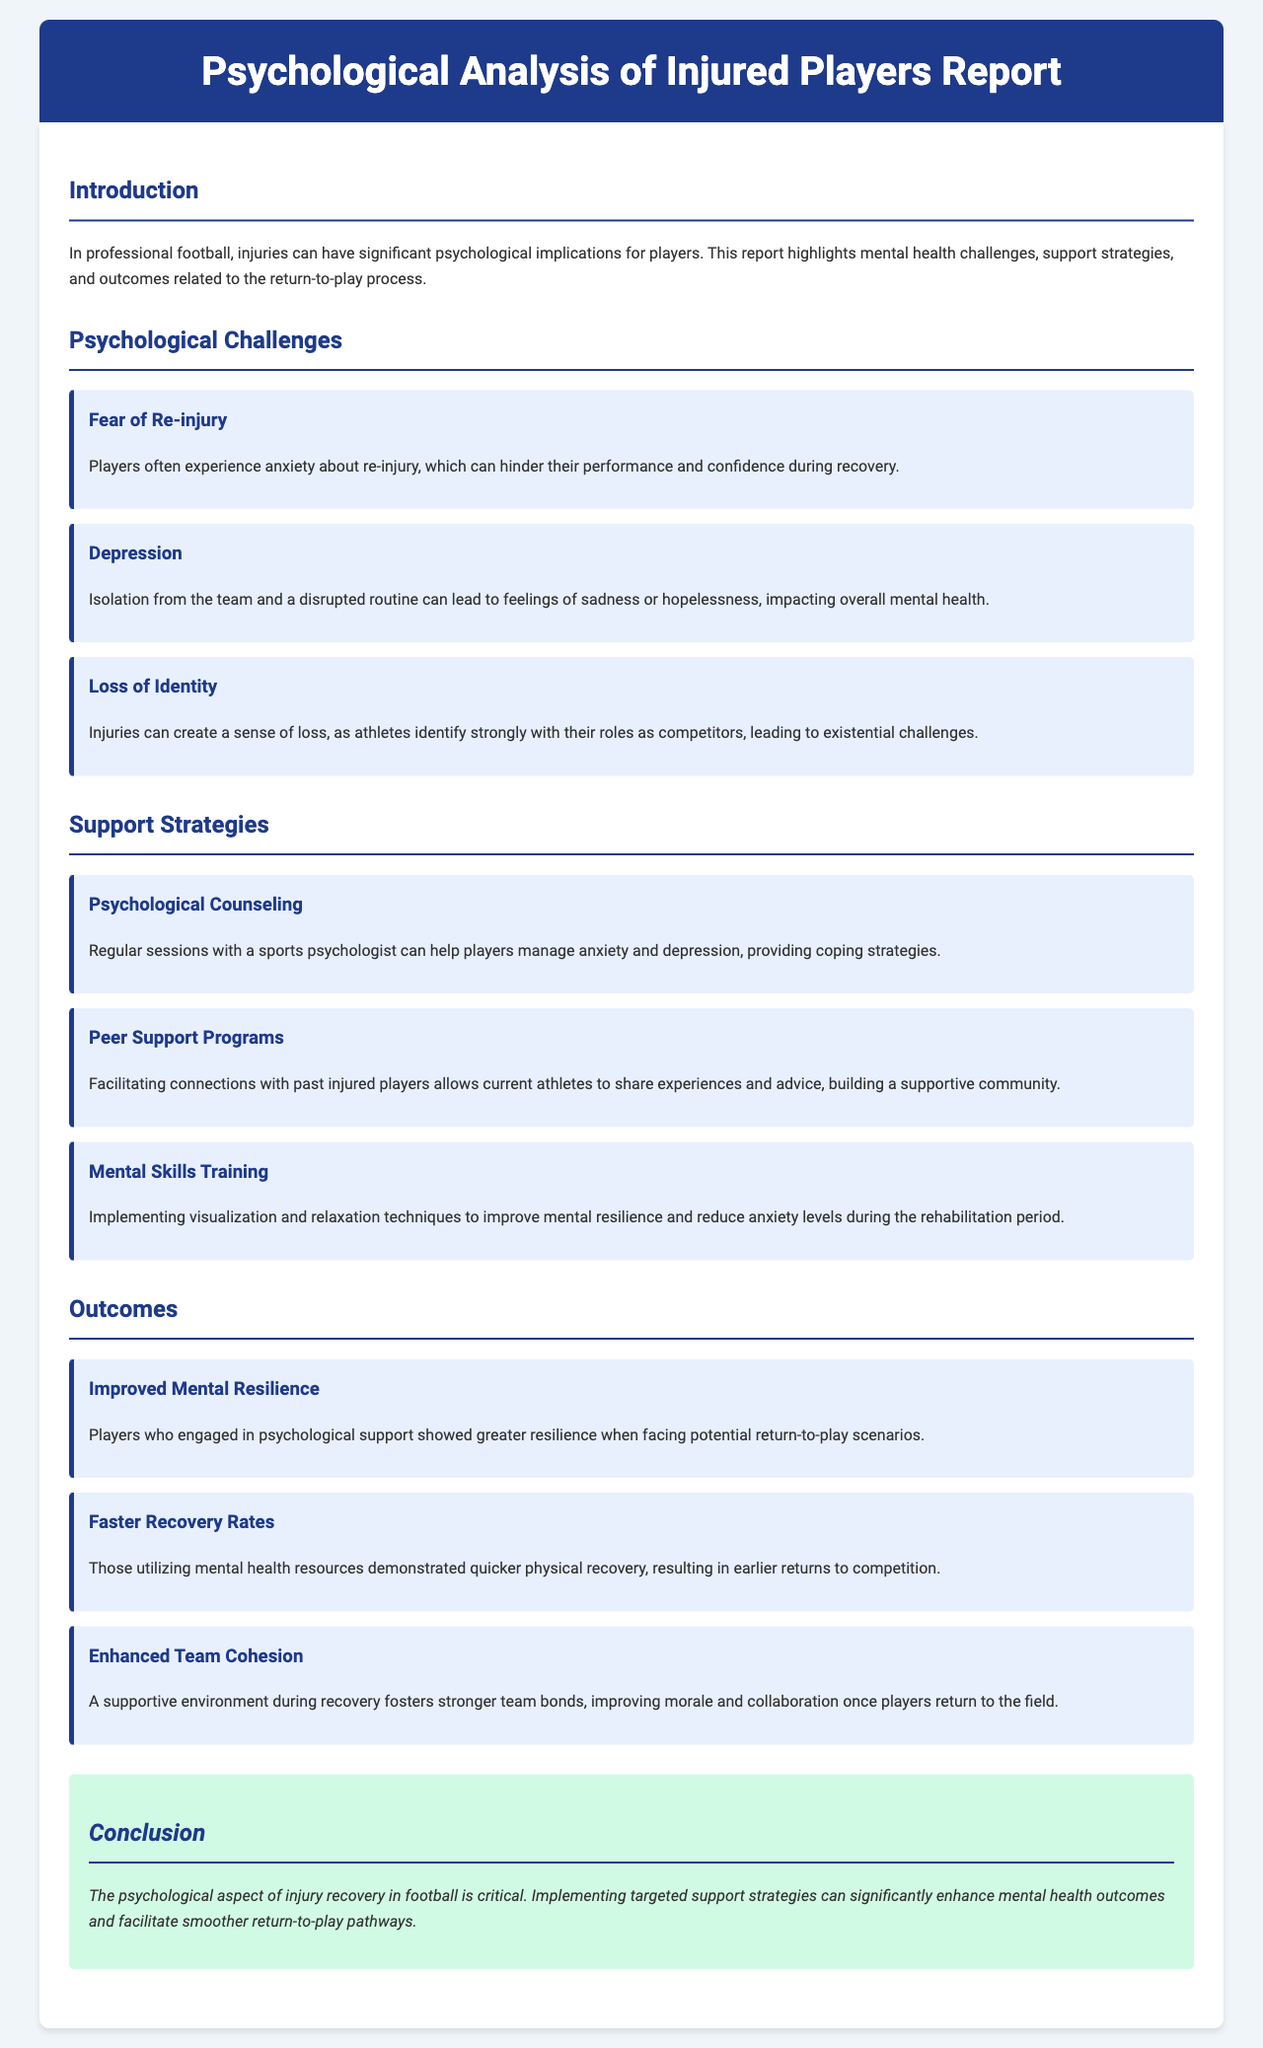What are the psychological challenges faced by injured players? The report outlines three main psychological challenges, including fear of re-injury, depression, and loss of identity.
Answer: Fear of re-injury, depression, loss of identity What is one strategy implemented to support injured players? The report lists several support strategies, including psychological counseling, peer support programs, and mental skills training, detailing how they help injured players.
Answer: Psychological counseling What outcome is reported for players who engaged in psychological support? The report states that players who participated in psychological support experienced improved mental resilience, among other positive impacts.
Answer: Improved mental resilience How many psychological challenges are identified in the report? The document specifies a total of three psychological challenges that players may face during recovery from injury.
Answer: Three What does the report suggest about the relationship between mental health resources and recovery rates? The report indicates that those utilizing mental health resources demonstrated quicker physical recovery and earlier returns to competition.
Answer: Quicker physical recovery Which support strategy involves connecting with past injured players? The report describes peer support programs as a way to facilitate connections with past injured players to share experiences and advice.
Answer: Peer support programs What type of document is this? The document provides an analysis of mental health issues pertaining specifically to sports injuries, and is thus categorized as a report.
Answer: Report What is highlighted as critical in the conclusion? The conclusion emphasizes the critical nature of addressing the psychological aspect of injury recovery in football.
Answer: Psychological aspect of injury recovery 